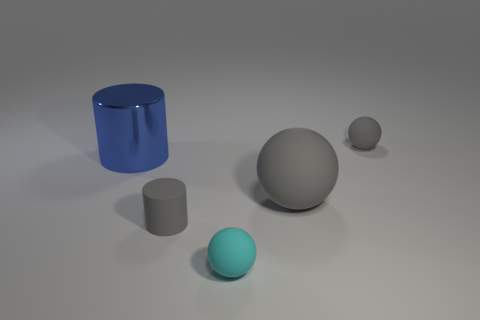Add 3 big yellow rubber spheres. How many objects exist? 8 Subtract all small spheres. How many spheres are left? 1 Subtract 0 cyan cylinders. How many objects are left? 5 Subtract all cylinders. How many objects are left? 3 Subtract all cyan cylinders. Subtract all purple cubes. How many cylinders are left? 2 Subtract all purple balls. How many purple cylinders are left? 0 Subtract all large brown metallic cylinders. Subtract all large spheres. How many objects are left? 4 Add 3 blue things. How many blue things are left? 4 Add 4 large blue things. How many large blue things exist? 5 Subtract all blue cylinders. How many cylinders are left? 1 